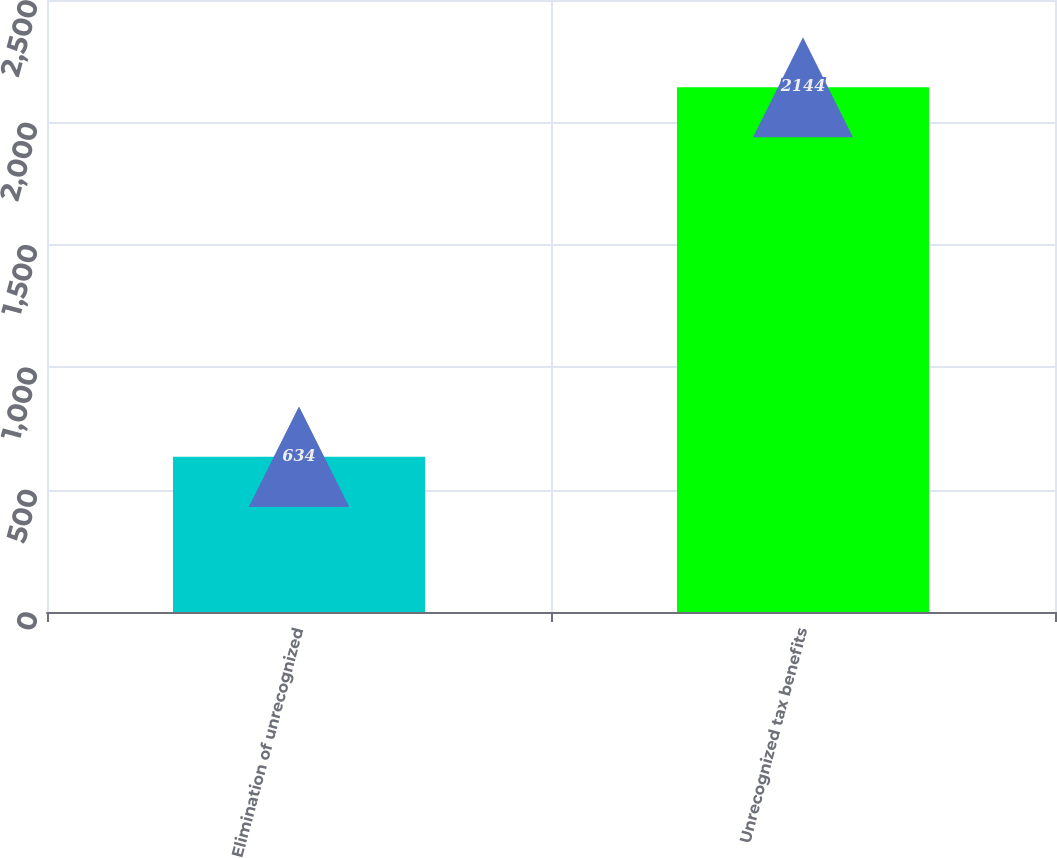<chart> <loc_0><loc_0><loc_500><loc_500><bar_chart><fcel>Elimination of unrecognized<fcel>Unrecognized tax benefits<nl><fcel>634<fcel>2144<nl></chart> 